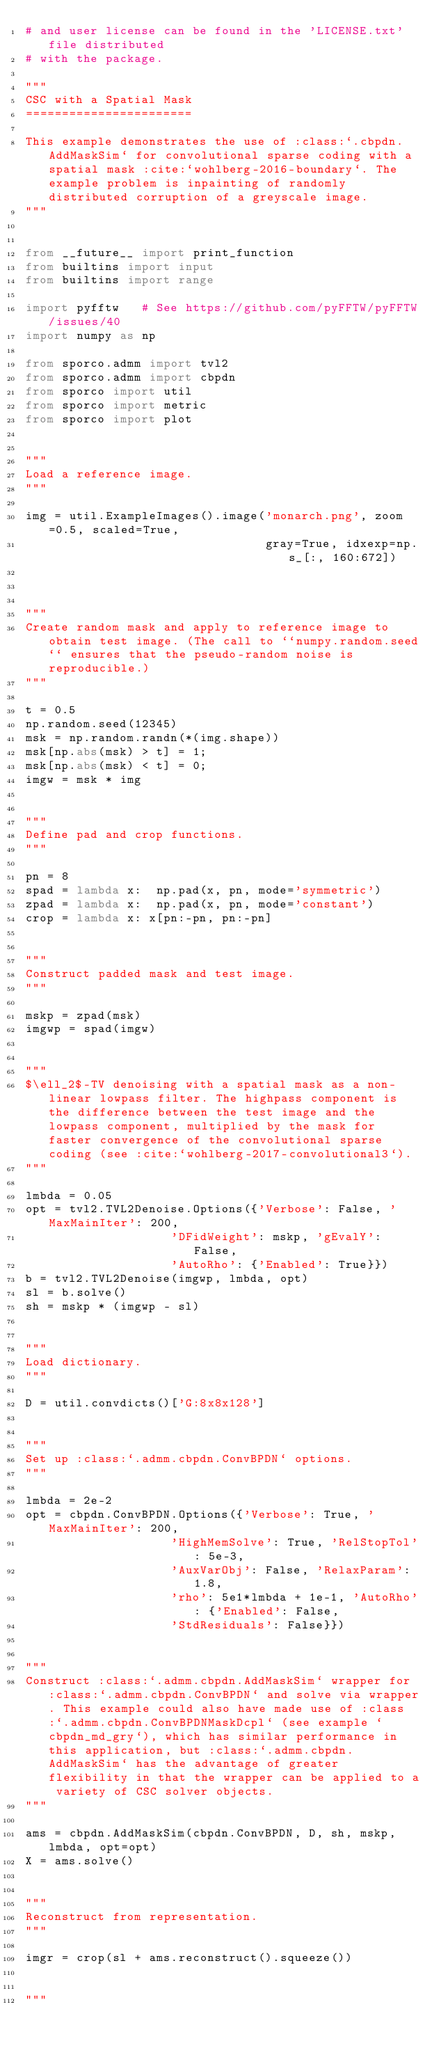Convert code to text. <code><loc_0><loc_0><loc_500><loc_500><_Python_># and user license can be found in the 'LICENSE.txt' file distributed
# with the package.

"""
CSC with a Spatial Mask
=======================

This example demonstrates the use of :class:`.cbpdn.AddMaskSim` for convolutional sparse coding with a spatial mask :cite:`wohlberg-2016-boundary`. The example problem is inpainting of randomly distributed corruption of a greyscale image.
"""


from __future__ import print_function
from builtins import input
from builtins import range

import pyfftw   # See https://github.com/pyFFTW/pyFFTW/issues/40
import numpy as np

from sporco.admm import tvl2
from sporco.admm import cbpdn
from sporco import util
from sporco import metric
from sporco import plot


"""
Load a reference image.
"""

img = util.ExampleImages().image('monarch.png', zoom=0.5, scaled=True,
                                 gray=True, idxexp=np.s_[:, 160:672])



"""
Create random mask and apply to reference image to obtain test image. (The call to ``numpy.random.seed`` ensures that the pseudo-random noise is reproducible.)
"""

t = 0.5
np.random.seed(12345)
msk = np.random.randn(*(img.shape))
msk[np.abs(msk) > t] = 1;
msk[np.abs(msk) < t] = 0;
imgw = msk * img


"""
Define pad and crop functions.
"""

pn = 8
spad = lambda x:  np.pad(x, pn, mode='symmetric')
zpad = lambda x:  np.pad(x, pn, mode='constant')
crop = lambda x: x[pn:-pn, pn:-pn]


"""
Construct padded mask and test image.
"""

mskp = zpad(msk)
imgwp = spad(imgw)


"""
$\ell_2$-TV denoising with a spatial mask as a non-linear lowpass filter. The highpass component is the difference between the test image and the lowpass component, multiplied by the mask for faster convergence of the convolutional sparse coding (see :cite:`wohlberg-2017-convolutional3`).
"""

lmbda = 0.05
opt = tvl2.TVL2Denoise.Options({'Verbose': False, 'MaxMainIter': 200,
                    'DFidWeight': mskp, 'gEvalY': False,
                    'AutoRho': {'Enabled': True}})
b = tvl2.TVL2Denoise(imgwp, lmbda, opt)
sl = b.solve()
sh = mskp * (imgwp - sl)


"""
Load dictionary.
"""

D = util.convdicts()['G:8x8x128']


"""
Set up :class:`.admm.cbpdn.ConvBPDN` options.
"""

lmbda = 2e-2
opt = cbpdn.ConvBPDN.Options({'Verbose': True, 'MaxMainIter': 200,
                    'HighMemSolve': True, 'RelStopTol': 5e-3,
                    'AuxVarObj': False, 'RelaxParam': 1.8,
                    'rho': 5e1*lmbda + 1e-1, 'AutoRho': {'Enabled': False,
                    'StdResiduals': False}})


"""
Construct :class:`.admm.cbpdn.AddMaskSim` wrapper for :class:`.admm.cbpdn.ConvBPDN` and solve via wrapper. This example could also have made use of :class:`.admm.cbpdn.ConvBPDNMaskDcpl` (see example `cbpdn_md_gry`), which has similar performance in this application, but :class:`.admm.cbpdn.AddMaskSim` has the advantage of greater flexibility in that the wrapper can be applied to a variety of CSC solver objects.
"""

ams = cbpdn.AddMaskSim(cbpdn.ConvBPDN, D, sh, mskp, lmbda, opt=opt)
X = ams.solve()


"""
Reconstruct from representation.
"""

imgr = crop(sl + ams.reconstruct().squeeze())


"""</code> 